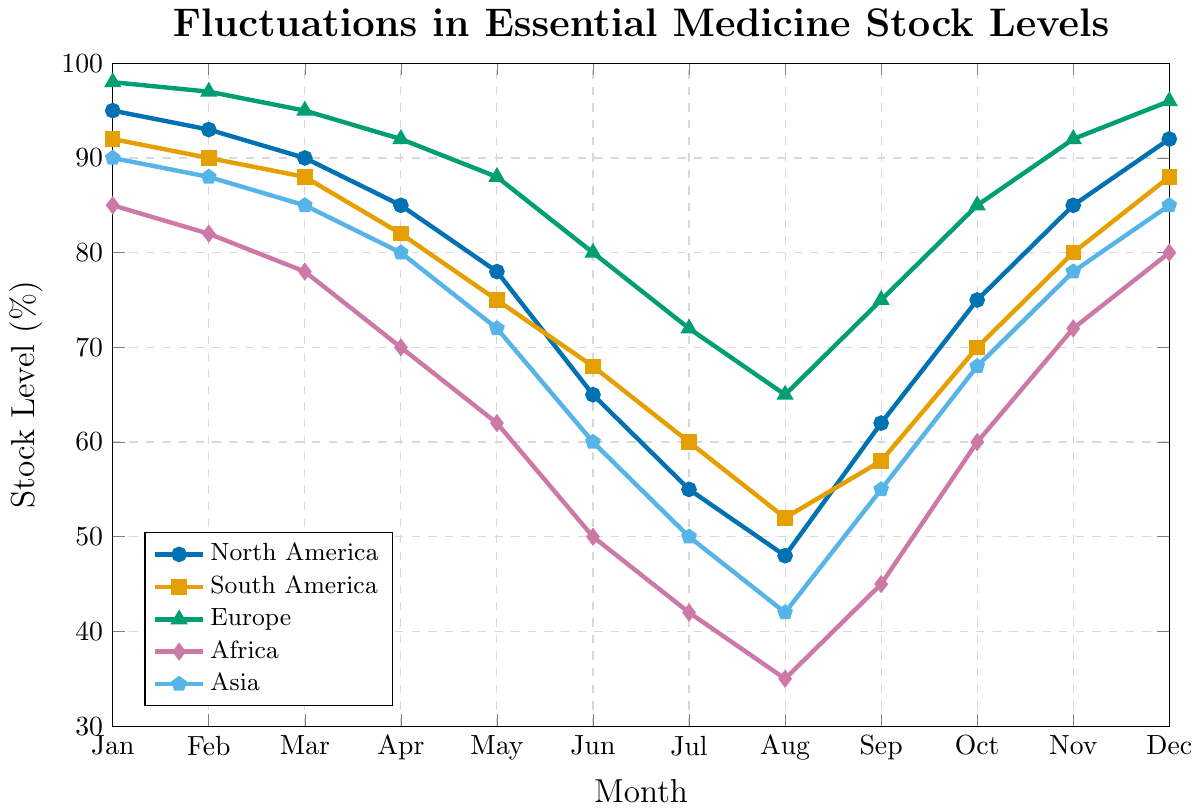What region had the highest essential medicine stock level at the beginning of the year (January)? The highest essential medicine stock levels for January can be identified by looking at the plotted points for each region at the x-coordinate corresponding to January. Europe had the highest stock level at 98%.
Answer: Europe How does the stock level in North America fluctuate between April and August? Observing the plot for North America (marked by a specific color), you can see that in April, the level is at 85%. It then decreases month by month until August, where it is at its lowest level of 48%.
Answer: Gradual decrease from 85% to 48% What is the percentage difference in stock levels between Africa and Europe in December? In December, Europe has a stock level of 96%, and Africa has 80%. The percentage difference can be calculated by subtracting Africa's level from Europe's: 96% - 80% = 16%.
Answer: 16% Which region had the most significant increase in stock levels from August to September? By examining the slope of the plot lines between August and September, the region whose plot line has the highest positive slope will have the significant increase. North America shows the most considerable increase from 48% to 62%.
Answer: North America What is the average stock level in Asia over the year? To find the average stock level for Asia, sum the stock levels for each month and then divide by the number of months (12). (90+88+85+80+72+60+50+42+55+68+78+85)/12 = 70.0%.
Answer: 70% Which regions had stock levels below 50% during any month of the year? Examine the y-values for each region's plot line; those that go below 50% at any point indicate stock levels below 50%. Africa and Asia go below 50% in several months.
Answer: Africa and Asia In which month did South America experience the lowest stock level and what was the percentage? By finding the point with the lowest y-value on South America's plot line, you'll see that in August the stock level was 52%.
Answer: August, 52% Compare the total decline in stock levels for Africa and South America from January to July. Which region had a greater decrease? Calculate the difference between the stock levels in January and July for both regions. Africa: 85% - 42% = 43%; South America: 92% - 60% = 32%. Africa experienced a greater decrease.
Answer: Africa If you were to prioritize which region to send additional supplies to in July, based on the stock levels alone, which region would it be? From the plot, Africa has the lowest stock level in July, standing at 42%. Therefore, Africa should be the priority.
Answer: Africa What is the trend of the essential medicine stock levels in Europe from Jun to Dec? Observing the plot for Europe from June to December, the stock level first decreases from 80% to 65% in August, then increases each month, reaching 96% by December.
Answer: Decreases first, then increases 